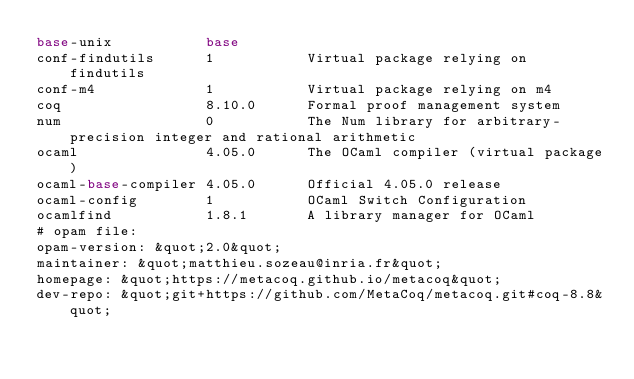Convert code to text. <code><loc_0><loc_0><loc_500><loc_500><_HTML_>base-unix           base
conf-findutils      1           Virtual package relying on findutils
conf-m4             1           Virtual package relying on m4
coq                 8.10.0      Formal proof management system
num                 0           The Num library for arbitrary-precision integer and rational arithmetic
ocaml               4.05.0      The OCaml compiler (virtual package)
ocaml-base-compiler 4.05.0      Official 4.05.0 release
ocaml-config        1           OCaml Switch Configuration
ocamlfind           1.8.1       A library manager for OCaml
# opam file:
opam-version: &quot;2.0&quot;
maintainer: &quot;matthieu.sozeau@inria.fr&quot;
homepage: &quot;https://metacoq.github.io/metacoq&quot;
dev-repo: &quot;git+https://github.com/MetaCoq/metacoq.git#coq-8.8&quot;</code> 